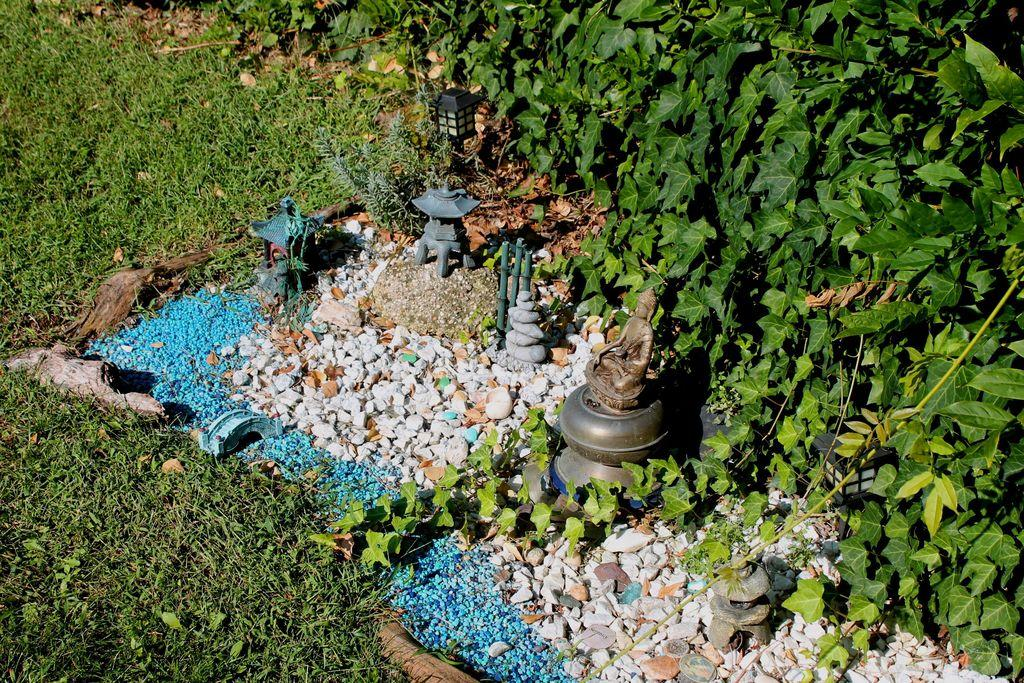What type of artwork is present in the image? There are sculptures in the image. What can be found at the bottom of the image? There are stones and grass at the bottom of the image. What type of vegetation is visible in the background of the image? There are plants in the background of the image. Can you see a rat eating a pickle in the image? There is no rat or pickle present in the image. 